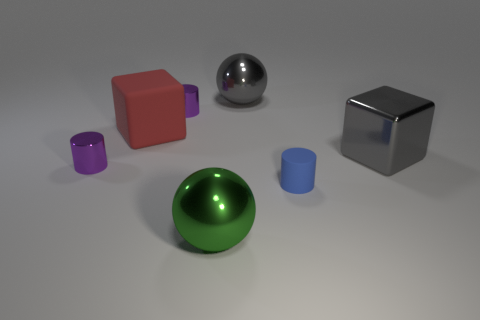There is a tiny cylinder on the right side of the big green metal thing; how many rubber cubes are in front of it?
Offer a terse response. 0. How many things are small cylinders or big matte blocks?
Offer a very short reply. 4. What material is the blue cylinder?
Offer a very short reply. Rubber. How many large metal objects are both left of the large gray block and behind the blue matte cylinder?
Ensure brevity in your answer.  1. Is the gray ball the same size as the green sphere?
Provide a short and direct response. Yes. Does the gray metallic ball that is on the right side of the red cube have the same size as the green metal object?
Your answer should be very brief. Yes. The big metal sphere on the right side of the green metallic sphere is what color?
Keep it short and to the point. Gray. What number of large rubber things are there?
Offer a very short reply. 1. What is the shape of the red object that is made of the same material as the small blue cylinder?
Make the answer very short. Cube. Do the big cube that is on the right side of the blue cylinder and the big sphere that is behind the large red cube have the same color?
Your answer should be very brief. Yes. 